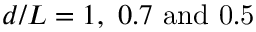Convert formula to latex. <formula><loc_0><loc_0><loc_500><loc_500>d / L = 1 , \ 0 . 7 \ { a n d } \ 0 . 5</formula> 